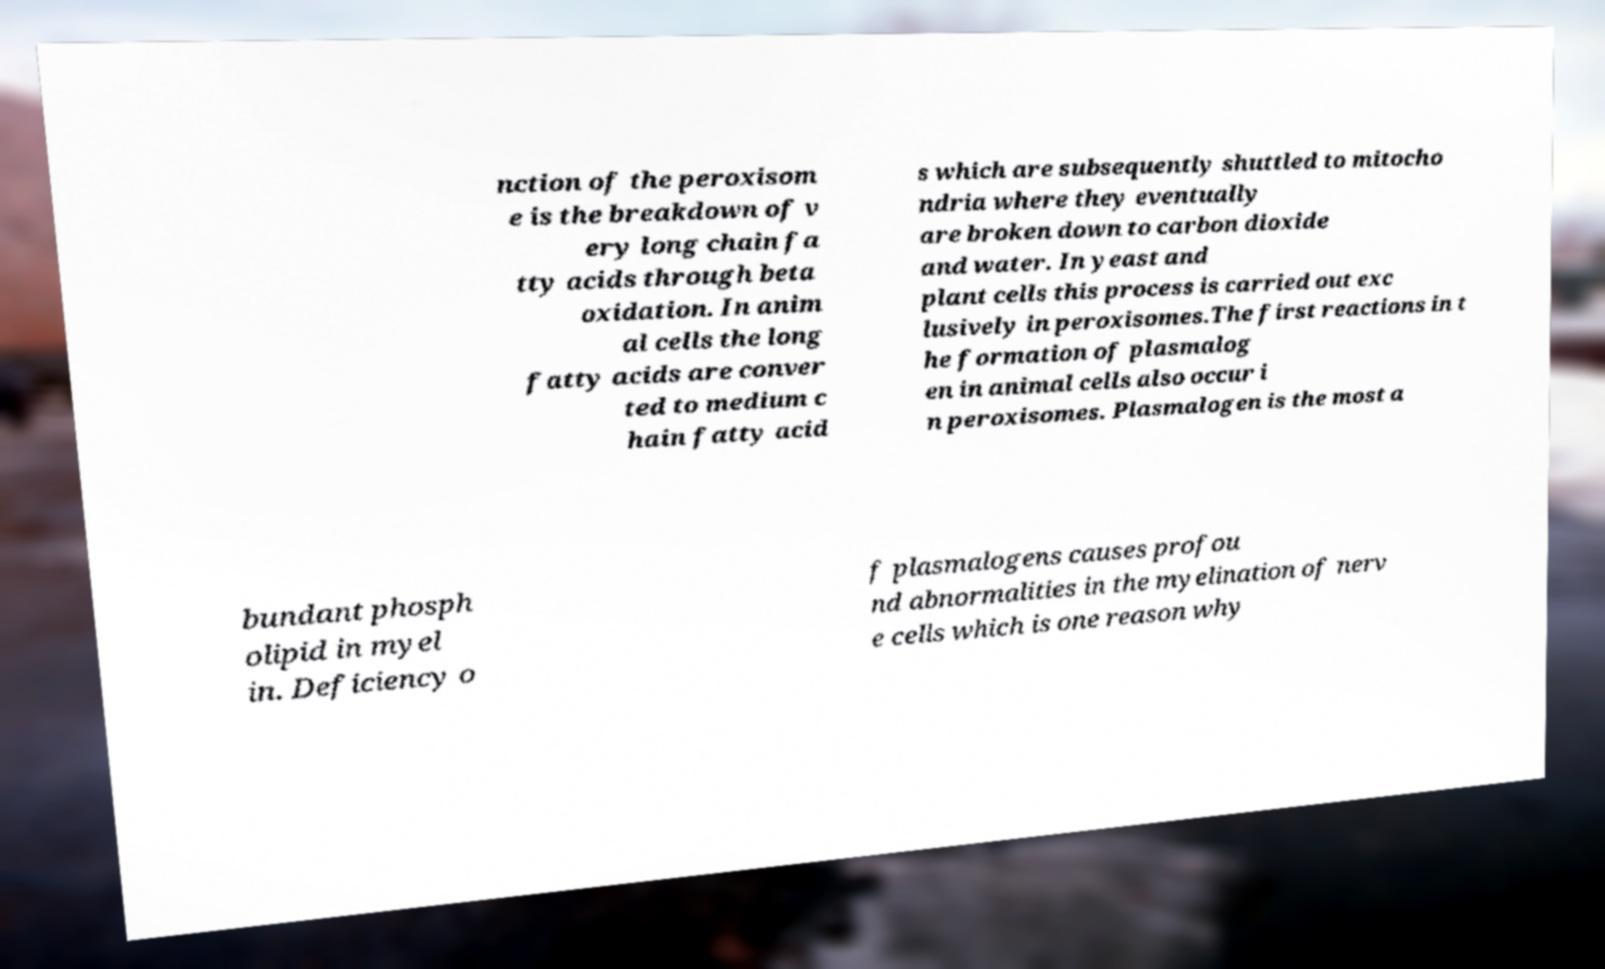Could you assist in decoding the text presented in this image and type it out clearly? nction of the peroxisom e is the breakdown of v ery long chain fa tty acids through beta oxidation. In anim al cells the long fatty acids are conver ted to medium c hain fatty acid s which are subsequently shuttled to mitocho ndria where they eventually are broken down to carbon dioxide and water. In yeast and plant cells this process is carried out exc lusively in peroxisomes.The first reactions in t he formation of plasmalog en in animal cells also occur i n peroxisomes. Plasmalogen is the most a bundant phosph olipid in myel in. Deficiency o f plasmalogens causes profou nd abnormalities in the myelination of nerv e cells which is one reason why 